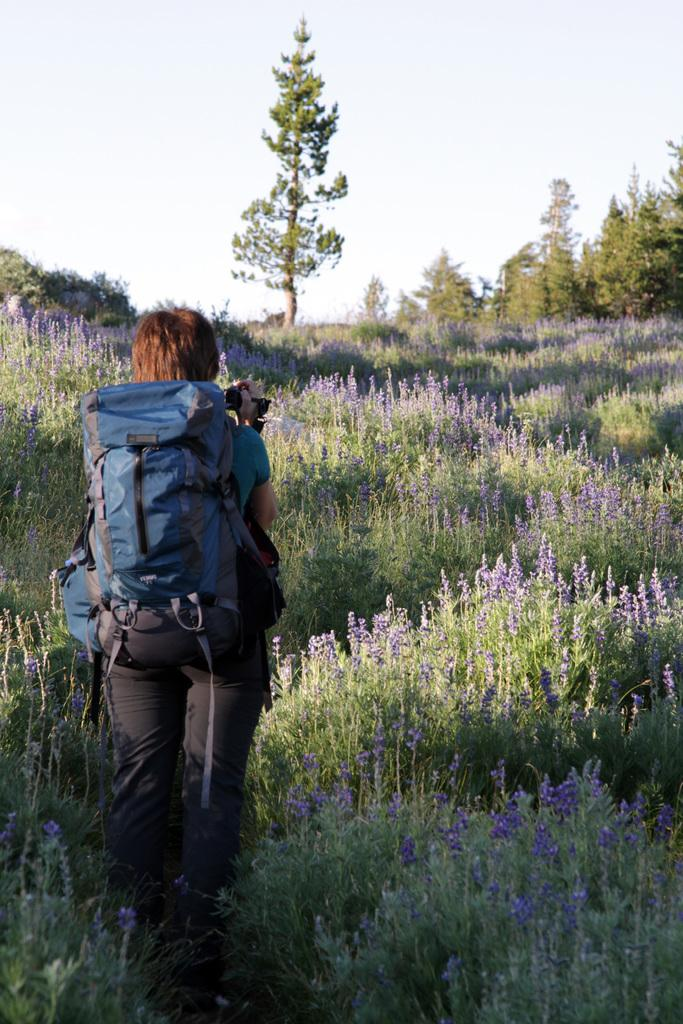What is the person in the image doing? The person is taking a picture. What is the person holding while taking the picture? The person is holding a camera. What is the person wearing that might be used for carrying items? The person is wearing a backpack. What is the subject of the picture being taken? The subject of the picture is a garden. What types of vegetation can be seen in the garden? There are plants, flowers, and trees in the garden. How many people are in the crowd in the image? There is no crowd present in the image; it features a person taking a picture of a garden. What type of horn can be seen in the image? There is no horn present in the image. 